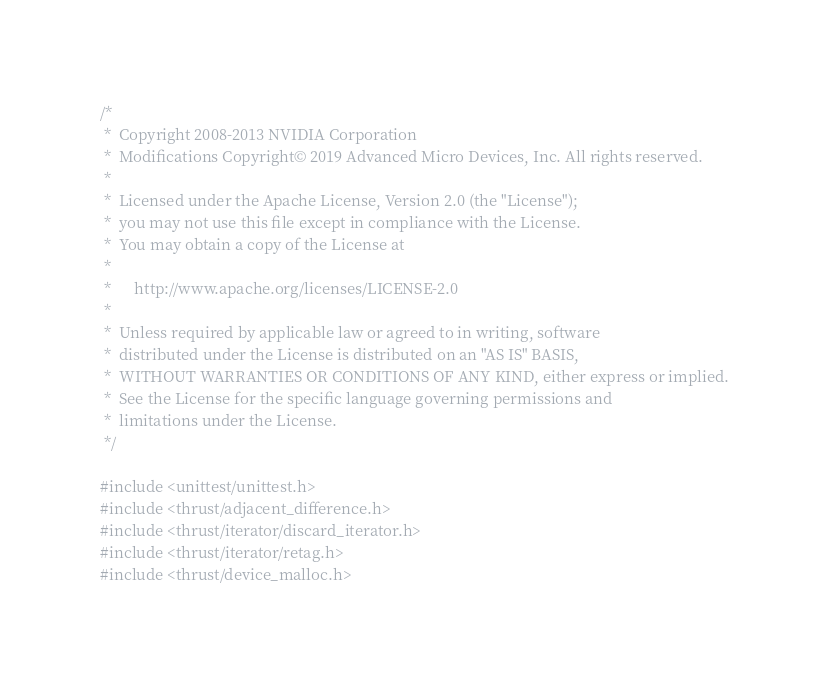Convert code to text. <code><loc_0><loc_0><loc_500><loc_500><_Cuda_>/*
 *  Copyright 2008-2013 NVIDIA Corporation
 *  Modifications Copyright© 2019 Advanced Micro Devices, Inc. All rights reserved.
 *
 *  Licensed under the Apache License, Version 2.0 (the "License");
 *  you may not use this file except in compliance with the License.
 *  You may obtain a copy of the License at
 *
 *      http://www.apache.org/licenses/LICENSE-2.0
 *
 *  Unless required by applicable law or agreed to in writing, software
 *  distributed under the License is distributed on an "AS IS" BASIS,
 *  WITHOUT WARRANTIES OR CONDITIONS OF ANY KIND, either express or implied.
 *  See the License for the specific language governing permissions and
 *  limitations under the License.
 */
 
#include <unittest/unittest.h>
#include <thrust/adjacent_difference.h>
#include <thrust/iterator/discard_iterator.h>
#include <thrust/iterator/retag.h>
#include <thrust/device_malloc.h></code> 